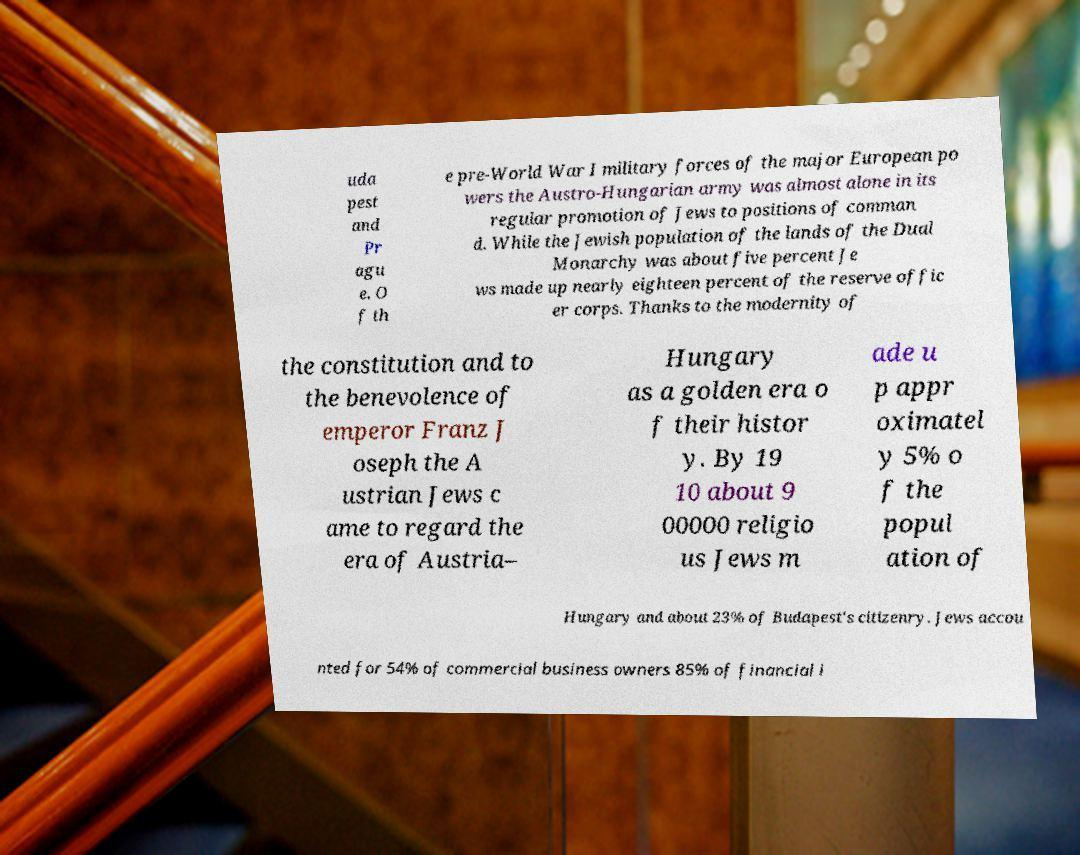Could you assist in decoding the text presented in this image and type it out clearly? uda pest and Pr agu e. O f th e pre-World War I military forces of the major European po wers the Austro-Hungarian army was almost alone in its regular promotion of Jews to positions of comman d. While the Jewish population of the lands of the Dual Monarchy was about five percent Je ws made up nearly eighteen percent of the reserve offic er corps. Thanks to the modernity of the constitution and to the benevolence of emperor Franz J oseph the A ustrian Jews c ame to regard the era of Austria– Hungary as a golden era o f their histor y. By 19 10 about 9 00000 religio us Jews m ade u p appr oximatel y 5% o f the popul ation of Hungary and about 23% of Budapest's citizenry. Jews accou nted for 54% of commercial business owners 85% of financial i 